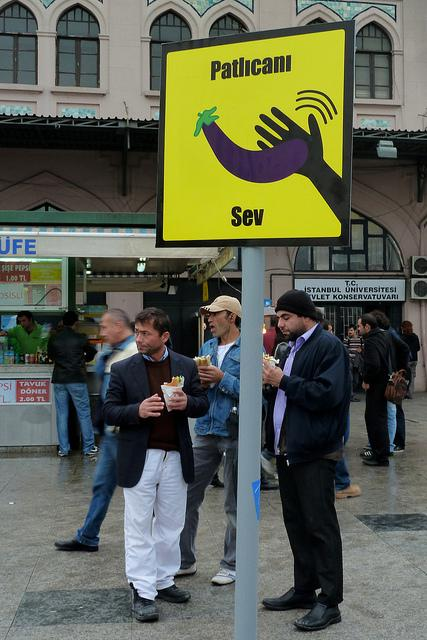What great empire once ruled this land?

Choices:
A) indian
B) serbian
C) mayan
D) ottoman ottoman 